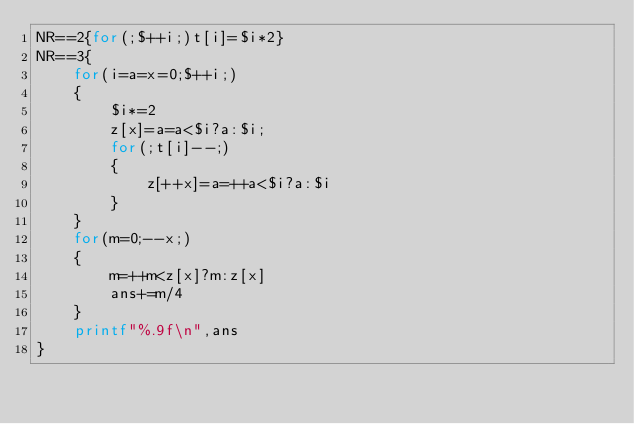Convert code to text. <code><loc_0><loc_0><loc_500><loc_500><_Awk_>NR==2{for(;$++i;)t[i]=$i*2}
NR==3{
	for(i=a=x=0;$++i;)
	{
		$i*=2
		z[x]=a=a<$i?a:$i;
		for(;t[i]--;)
		{
			z[++x]=a=++a<$i?a:$i
		}
	}
	for(m=0;--x;)
	{
		m=++m<z[x]?m:z[x]
		ans+=m/4
	}
	printf"%.9f\n",ans
}</code> 